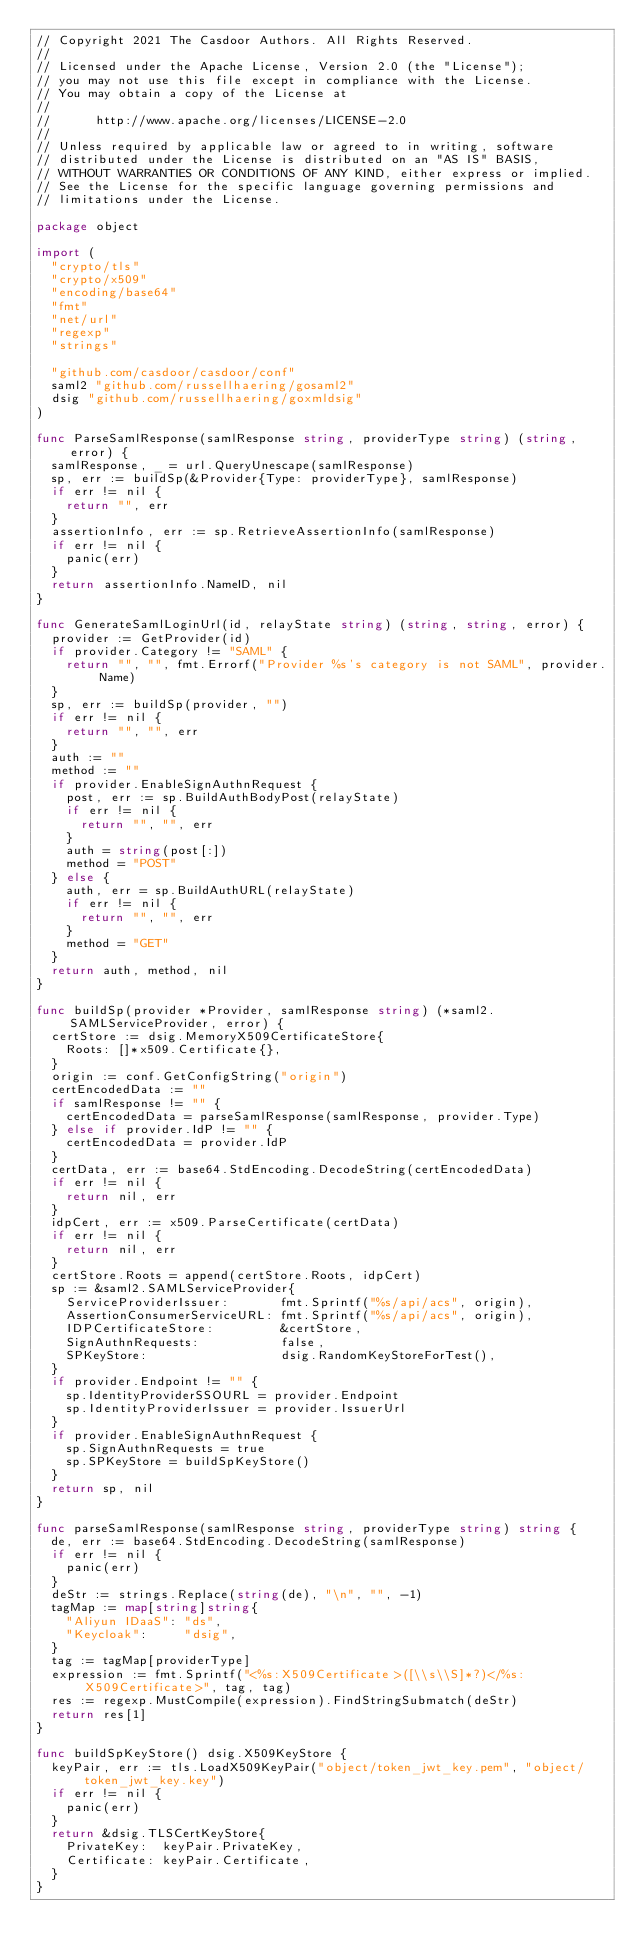Convert code to text. <code><loc_0><loc_0><loc_500><loc_500><_Go_>// Copyright 2021 The Casdoor Authors. All Rights Reserved.
//
// Licensed under the Apache License, Version 2.0 (the "License");
// you may not use this file except in compliance with the License.
// You may obtain a copy of the License at
//
//      http://www.apache.org/licenses/LICENSE-2.0
//
// Unless required by applicable law or agreed to in writing, software
// distributed under the License is distributed on an "AS IS" BASIS,
// WITHOUT WARRANTIES OR CONDITIONS OF ANY KIND, either express or implied.
// See the License for the specific language governing permissions and
// limitations under the License.

package object

import (
	"crypto/tls"
	"crypto/x509"
	"encoding/base64"
	"fmt"
	"net/url"
	"regexp"
	"strings"

	"github.com/casdoor/casdoor/conf"
	saml2 "github.com/russellhaering/gosaml2"
	dsig "github.com/russellhaering/goxmldsig"
)

func ParseSamlResponse(samlResponse string, providerType string) (string, error) {
	samlResponse, _ = url.QueryUnescape(samlResponse)
	sp, err := buildSp(&Provider{Type: providerType}, samlResponse)
	if err != nil {
		return "", err
	}
	assertionInfo, err := sp.RetrieveAssertionInfo(samlResponse)
	if err != nil {
		panic(err)
	}
	return assertionInfo.NameID, nil
}

func GenerateSamlLoginUrl(id, relayState string) (string, string, error) {
	provider := GetProvider(id)
	if provider.Category != "SAML" {
		return "", "", fmt.Errorf("Provider %s's category is not SAML", provider.Name)
	}
	sp, err := buildSp(provider, "")
	if err != nil {
		return "", "", err
	}
	auth := ""
	method := ""
	if provider.EnableSignAuthnRequest {
		post, err := sp.BuildAuthBodyPost(relayState)
		if err != nil {
			return "", "", err
		}
		auth = string(post[:])
		method = "POST"
	} else {
		auth, err = sp.BuildAuthURL(relayState)
		if err != nil {
			return "", "", err
		}
		method = "GET"
	}
	return auth, method, nil
}

func buildSp(provider *Provider, samlResponse string) (*saml2.SAMLServiceProvider, error) {
	certStore := dsig.MemoryX509CertificateStore{
		Roots: []*x509.Certificate{},
	}
	origin := conf.GetConfigString("origin")
	certEncodedData := ""
	if samlResponse != "" {
		certEncodedData = parseSamlResponse(samlResponse, provider.Type)
	} else if provider.IdP != "" {
		certEncodedData = provider.IdP
	}
	certData, err := base64.StdEncoding.DecodeString(certEncodedData)
	if err != nil {
		return nil, err
	}
	idpCert, err := x509.ParseCertificate(certData)
	if err != nil {
		return nil, err
	}
	certStore.Roots = append(certStore.Roots, idpCert)
	sp := &saml2.SAMLServiceProvider{
		ServiceProviderIssuer:       fmt.Sprintf("%s/api/acs", origin),
		AssertionConsumerServiceURL: fmt.Sprintf("%s/api/acs", origin),
		IDPCertificateStore:         &certStore,
		SignAuthnRequests:           false,
		SPKeyStore:                  dsig.RandomKeyStoreForTest(),
	}
	if provider.Endpoint != "" {
		sp.IdentityProviderSSOURL = provider.Endpoint
		sp.IdentityProviderIssuer = provider.IssuerUrl
	}
	if provider.EnableSignAuthnRequest {
		sp.SignAuthnRequests = true
		sp.SPKeyStore = buildSpKeyStore()
	}
	return sp, nil
}

func parseSamlResponse(samlResponse string, providerType string) string {
	de, err := base64.StdEncoding.DecodeString(samlResponse)
	if err != nil {
		panic(err)
	}
	deStr := strings.Replace(string(de), "\n", "", -1)
	tagMap := map[string]string{
		"Aliyun IDaaS": "ds",
		"Keycloak":     "dsig",
	}
	tag := tagMap[providerType]
	expression := fmt.Sprintf("<%s:X509Certificate>([\\s\\S]*?)</%s:X509Certificate>", tag, tag)
	res := regexp.MustCompile(expression).FindStringSubmatch(deStr)
	return res[1]
}

func buildSpKeyStore() dsig.X509KeyStore {
	keyPair, err := tls.LoadX509KeyPair("object/token_jwt_key.pem", "object/token_jwt_key.key")
	if err != nil {
		panic(err)
	}
	return &dsig.TLSCertKeyStore{
		PrivateKey:  keyPair.PrivateKey,
		Certificate: keyPair.Certificate,
	}
}
</code> 